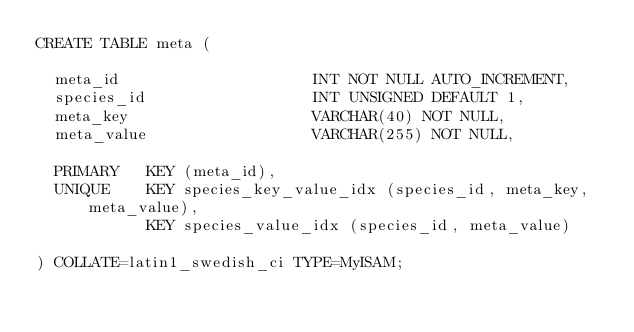<code> <loc_0><loc_0><loc_500><loc_500><_SQL_>CREATE TABLE meta (

  meta_id                     INT NOT NULL AUTO_INCREMENT,
  species_id                  INT UNSIGNED DEFAULT 1,
  meta_key                    VARCHAR(40) NOT NULL,
  meta_value                  VARCHAR(255) NOT NULL,

  PRIMARY   KEY (meta_id),
  UNIQUE    KEY species_key_value_idx (species_id, meta_key, meta_value),
            KEY species_value_idx (species_id, meta_value)

) COLLATE=latin1_swedish_ci TYPE=MyISAM;
</code> 